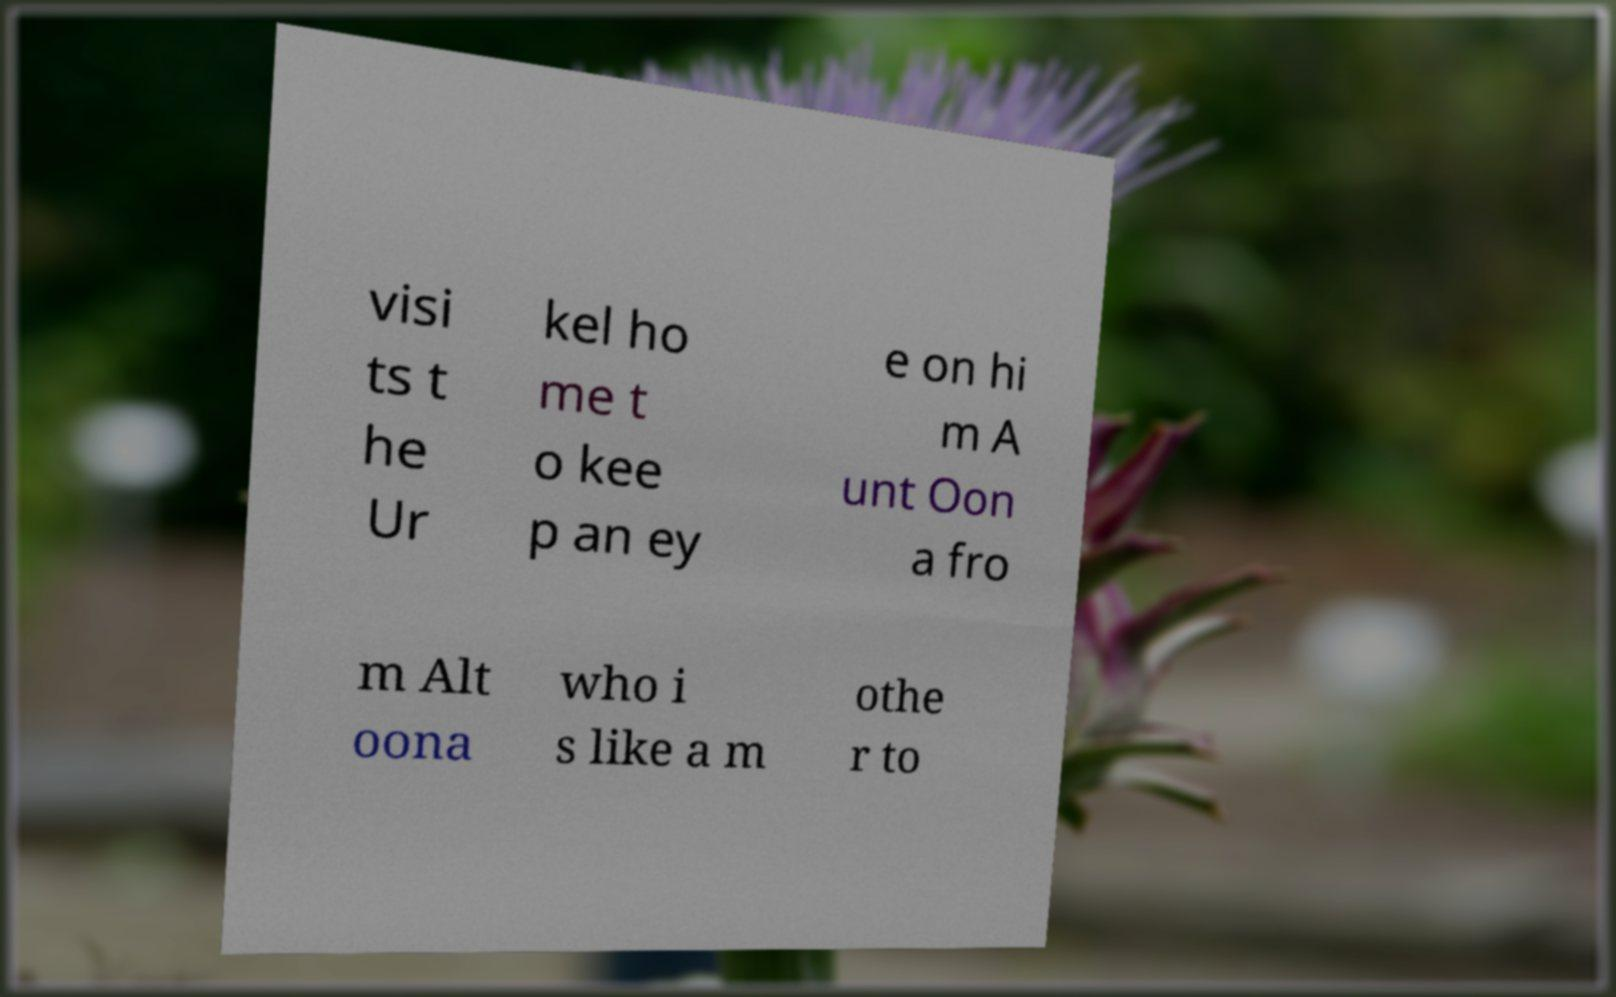What messages or text are displayed in this image? I need them in a readable, typed format. visi ts t he Ur kel ho me t o kee p an ey e on hi m A unt Oon a fro m Alt oona who i s like a m othe r to 